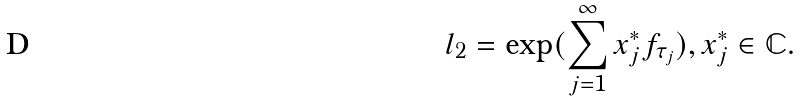<formula> <loc_0><loc_0><loc_500><loc_500>l _ { 2 } = \exp ( \sum _ { j = 1 } ^ { \infty } x _ { j } ^ { * } f _ { \tau _ { j } } ) , x _ { j } ^ { * } \in \mathbb { C } .</formula> 